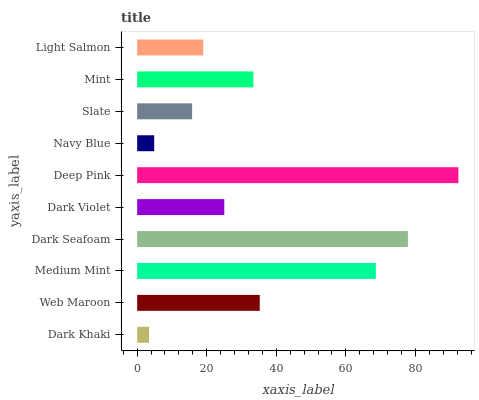Is Dark Khaki the minimum?
Answer yes or no. Yes. Is Deep Pink the maximum?
Answer yes or no. Yes. Is Web Maroon the minimum?
Answer yes or no. No. Is Web Maroon the maximum?
Answer yes or no. No. Is Web Maroon greater than Dark Khaki?
Answer yes or no. Yes. Is Dark Khaki less than Web Maroon?
Answer yes or no. Yes. Is Dark Khaki greater than Web Maroon?
Answer yes or no. No. Is Web Maroon less than Dark Khaki?
Answer yes or no. No. Is Mint the high median?
Answer yes or no. Yes. Is Dark Violet the low median?
Answer yes or no. Yes. Is Dark Violet the high median?
Answer yes or no. No. Is Slate the low median?
Answer yes or no. No. 